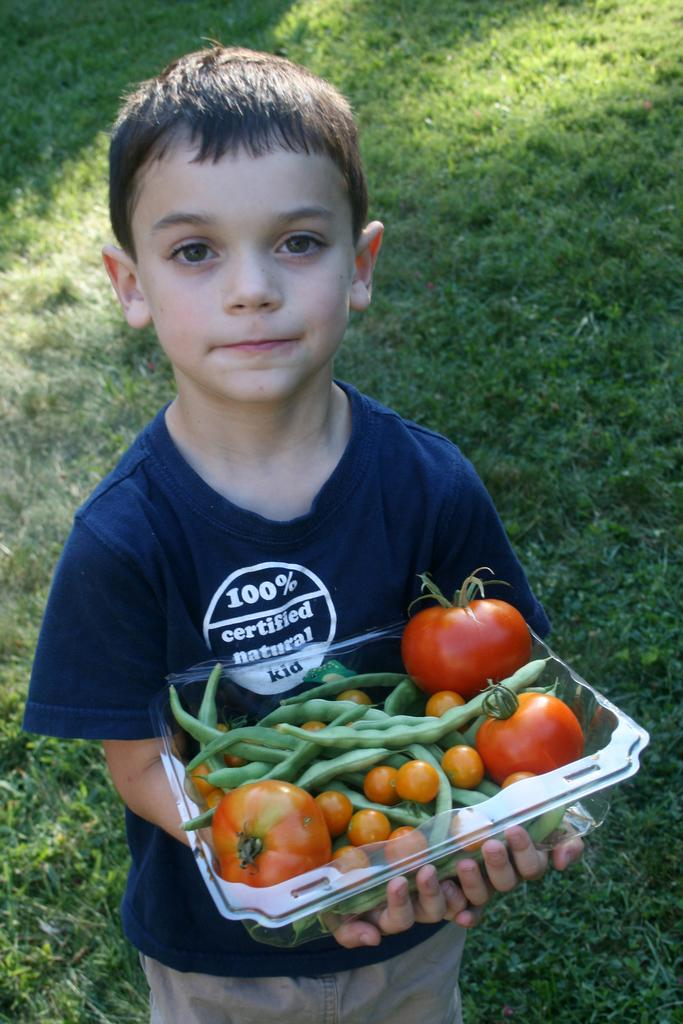What is the main subject of the image? The main subject of the image is a boy. What is the boy holding in the image? The boy is holding a box. What is inside the box? There are vegetables in the box. What type of surface is visible at the bottom of the image? There is grass at the bottom of the image. What type of toy can be seen in the boy's mouth in the image? There is no toy visible in the boy's mouth in the image. Can you tell me how many airplanes are flying in the sky in the image? There is no sky or airplanes present in the image; it features a boy holding a box of vegetables on a grassy surface. 